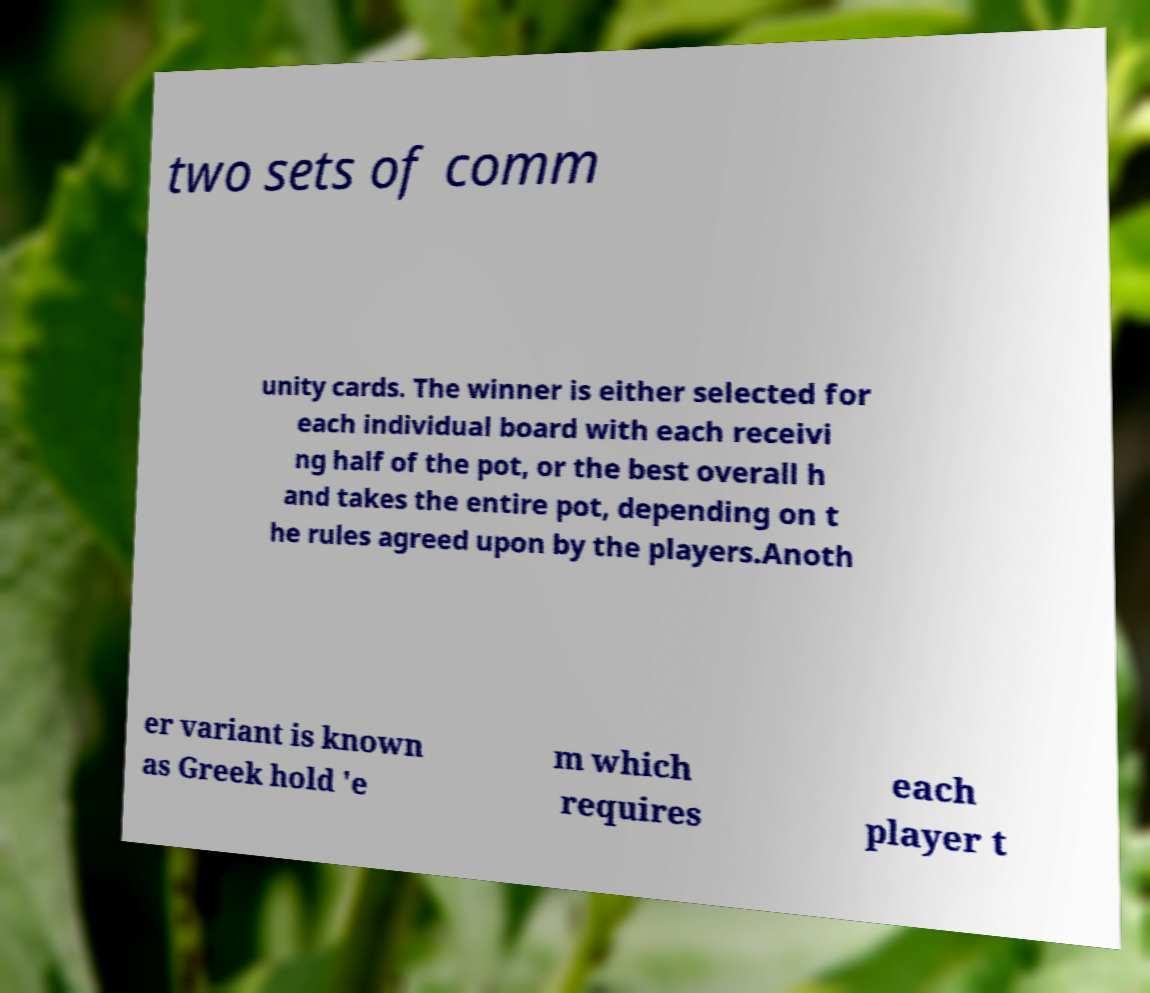There's text embedded in this image that I need extracted. Can you transcribe it verbatim? two sets of comm unity cards. The winner is either selected for each individual board with each receivi ng half of the pot, or the best overall h and takes the entire pot, depending on t he rules agreed upon by the players.Anoth er variant is known as Greek hold 'e m which requires each player t 